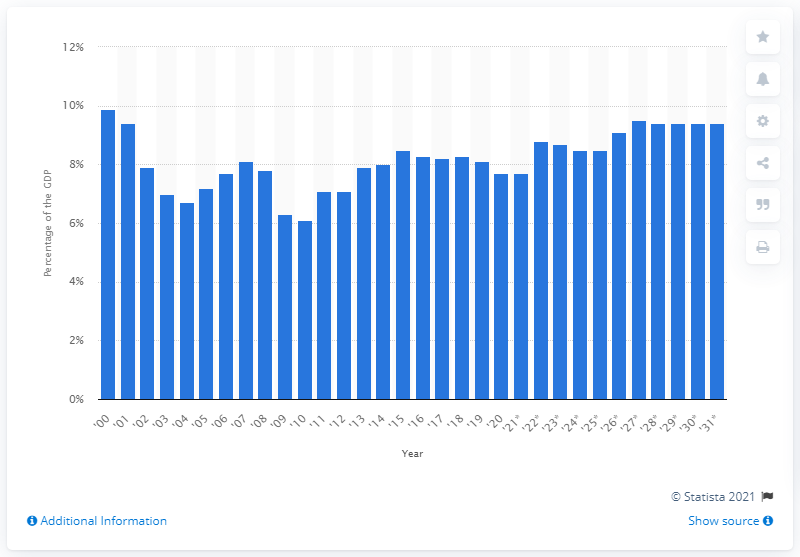Outline some significant characteristics in this image. The projected increase in income tax revenue for the U.S. in 2031 would be 9.4% of the country's GDP. In 2020, the income tax revenue represented approximately 7.7% of the total GDP of the United States. 